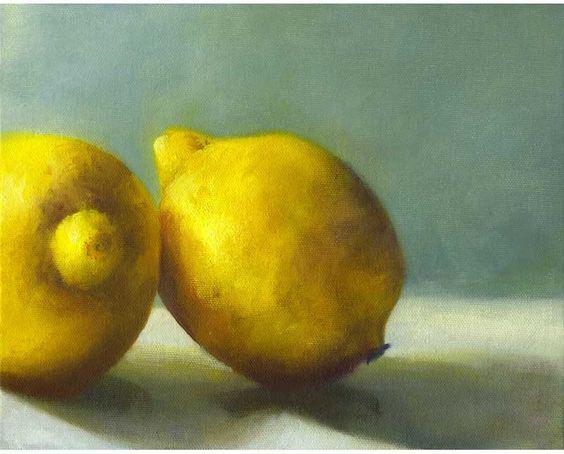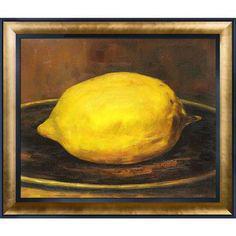The first image is the image on the left, the second image is the image on the right. Analyze the images presented: Is the assertion "The artwork of one image shows three whole lemons arranged in a bowl, while a second artwork image is of lemon wedges in blue shadows." valid? Answer yes or no. No. The first image is the image on the left, the second image is the image on the right. Analyze the images presented: Is the assertion "The fruit is sliced into quarters or smaller." valid? Answer yes or no. No. 